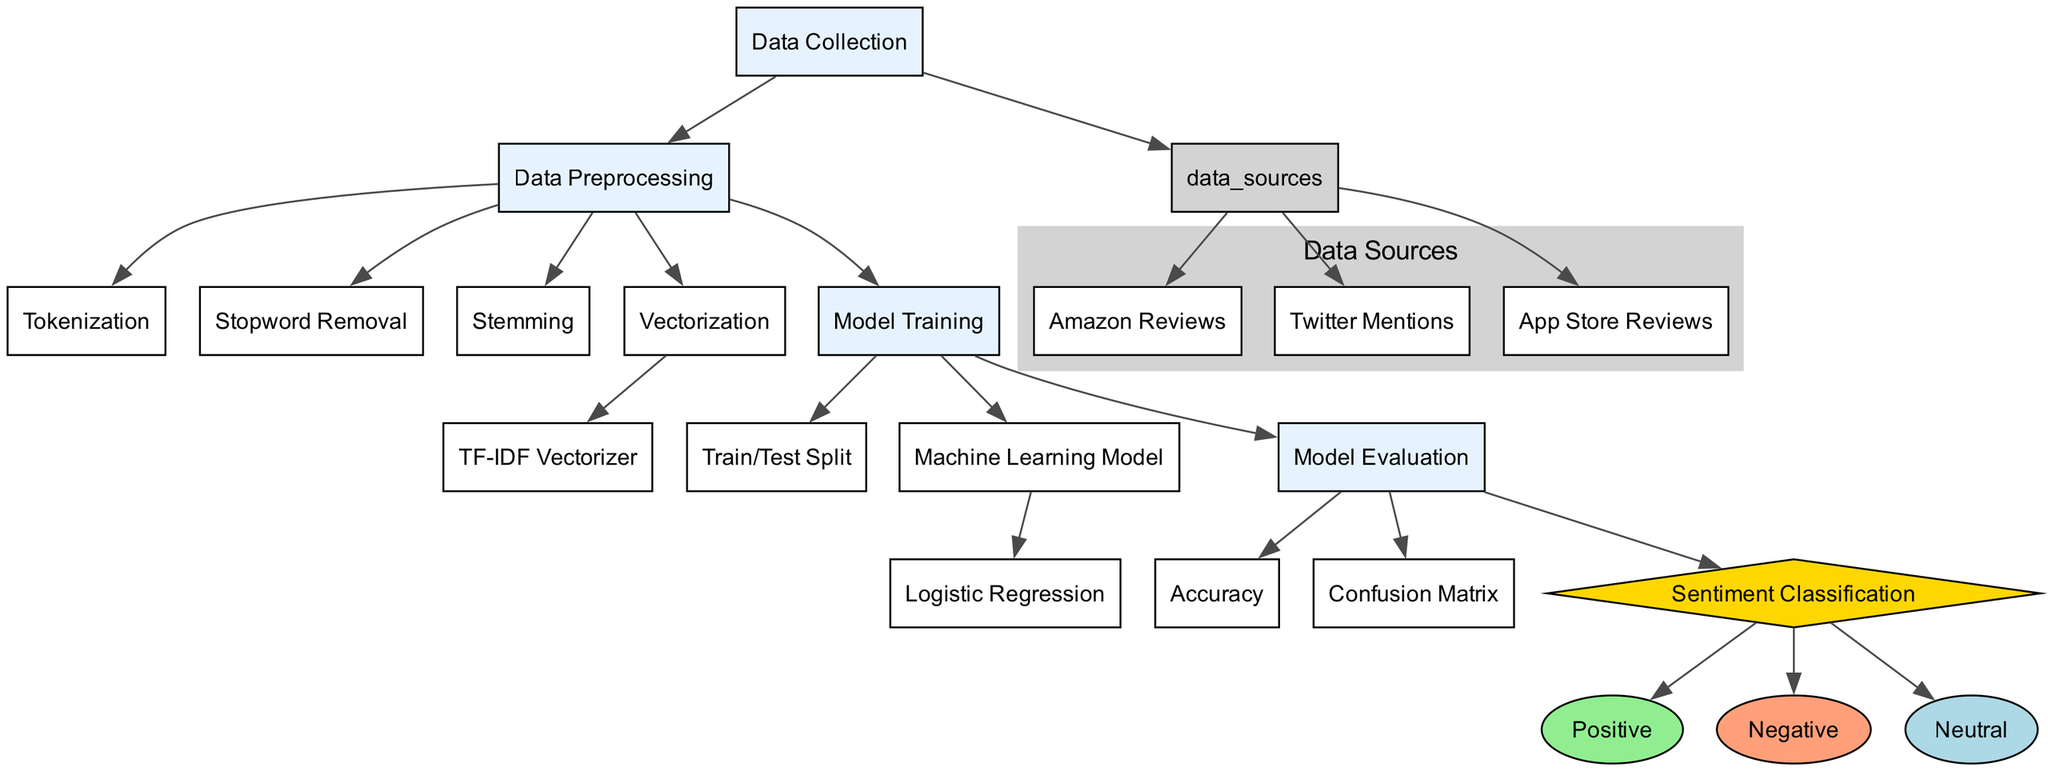What are the data sources used for sentiment analysis? The diagram lists three data sources: Amazon Reviews, Twitter Mentions, and App Store Reviews. These nodes branch out from the Data Sources node, showing they are part of the Data Collection process.
Answer: Amazon Reviews, Twitter Mentions, App Store Reviews How many nodes are there in total in the diagram? The diagram contains a total of 17 nodes, which include main processes, sub-processes, and sentiment classifications. Counting all unique nodes shown in the data provided confirms this total.
Answer: 17 Which node is represented as a diamond shape? The Sentiment Classification node is the only node represented as a diamond shape in the diagram, indicating it is a decision point based on the previous processes.
Answer: Sentiment Classification What process follows Data Preprocessing in the diagram? After data preprocessing, the next step is model training according to the directional arrows that flow from data preprocessing to model training. This step is essential for preparing the model to analyze sentiments.
Answer: Model Training How many types of sentiments are classified in the diagram? The diagram shows three types of sentiments classified: Positive, Negative, and Neutral, which branch out from the Sentiment Classification node. This indicates the output types of the analysis.
Answer: Three What is the purpose of the TF-IDF Vectorizer in the diagram? The TF-IDF Vectorizer is part of the Vectorization process and helps convert text data into numerical format which is usable for model training. It is a key part of transforming the text input into a form that can be analyzed.
Answer: Convert text to numerical format In which process is the Confusion Matrix used? The Confusion Matrix is utilized in the Model Evaluation process. This step is important for assessing how well the model classified the sentiments based on the actual results compared to predictions.
Answer: Model Evaluation Identify the machine learning model used in the diagram. The logistic regression node indicates that the machine learning model employed for sentiment analysis is logistic regression, which is a statistical method for classifying inputs into two or more classes.
Answer: Logistic Regression What is the final output of the sentiment classification process? The final output after sentiment classification is the breakdown of reviews into three categories: Positive, Negative, and Neutral, which indicates the overall sentiment of product reviews.
Answer: Positive, Negative, Neutral 